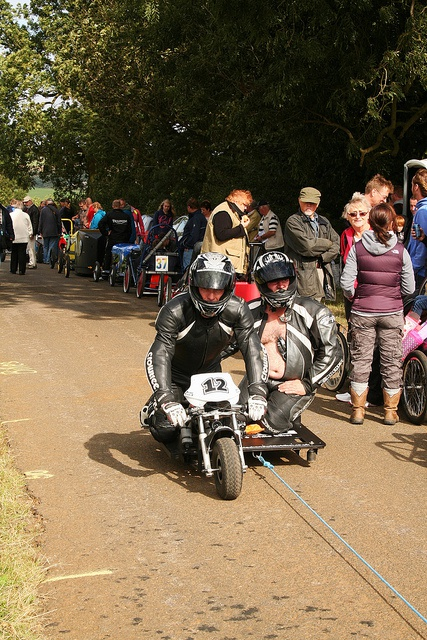Describe the objects in this image and their specific colors. I can see people in olive, black, gray, white, and darkgray tones, people in olive, black, gray, lightgray, and darkgray tones, people in olive, brown, darkgray, maroon, and black tones, motorcycle in olive, black, white, gray, and darkgray tones, and people in olive, black, maroon, brown, and gray tones in this image. 